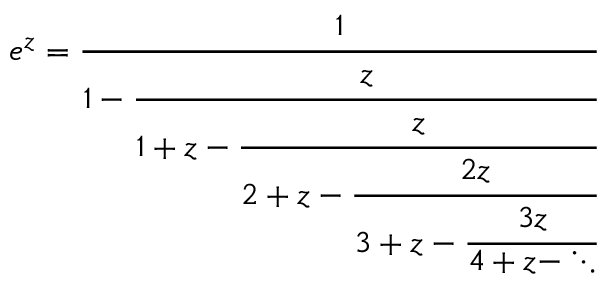Convert formula to latex. <formula><loc_0><loc_0><loc_500><loc_500>e ^ { z } = { \cfrac { 1 } { 1 - { \cfrac { z } { 1 + z - { \cfrac { z } { 2 + z - { \cfrac { 2 z } { 3 + z - { \cfrac { 3 z } { 4 + z - \ddots } } } } } } } } } }</formula> 